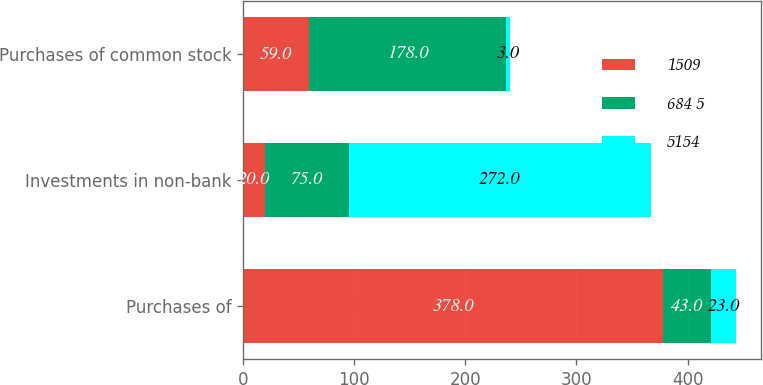Convert chart. <chart><loc_0><loc_0><loc_500><loc_500><stacked_bar_chart><ecel><fcel>Purchases of<fcel>Investments in non-bank<fcel>Purchases of common stock<nl><fcel>1509<fcel>378<fcel>20<fcel>59<nl><fcel>684 5<fcel>43<fcel>75<fcel>178<nl><fcel>5154<fcel>23<fcel>272<fcel>3<nl></chart> 